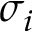<formula> <loc_0><loc_0><loc_500><loc_500>\sigma _ { i }</formula> 